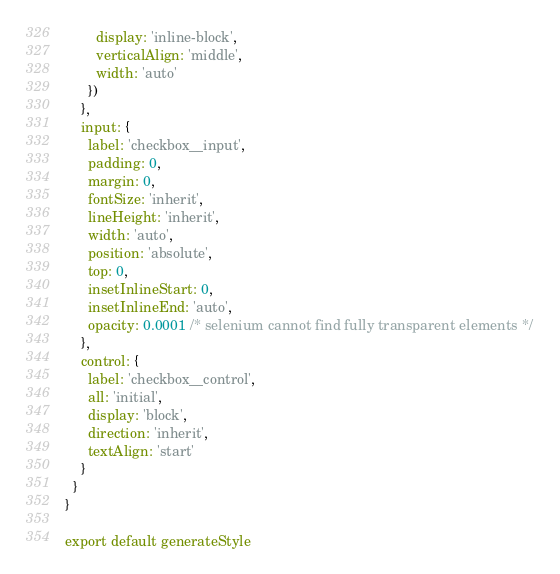Convert code to text. <code><loc_0><loc_0><loc_500><loc_500><_TypeScript_>        display: 'inline-block',
        verticalAlign: 'middle',
        width: 'auto'
      })
    },
    input: {
      label: 'checkbox__input',
      padding: 0,
      margin: 0,
      fontSize: 'inherit',
      lineHeight: 'inherit',
      width: 'auto',
      position: 'absolute',
      top: 0,
      insetInlineStart: 0,
      insetInlineEnd: 'auto',
      opacity: 0.0001 /* selenium cannot find fully transparent elements */
    },
    control: {
      label: 'checkbox__control',
      all: 'initial',
      display: 'block',
      direction: 'inherit',
      textAlign: 'start'
    }
  }
}

export default generateStyle
</code> 